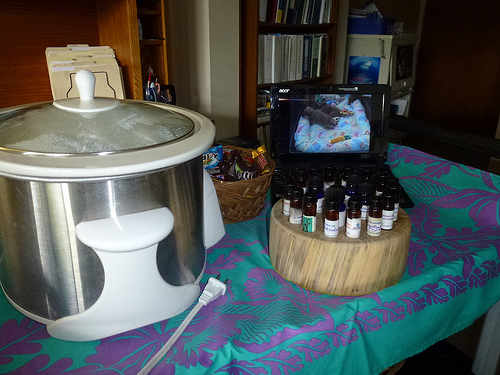<image>
Is the basket in front of the folder? No. The basket is not in front of the folder. The spatial positioning shows a different relationship between these objects. 